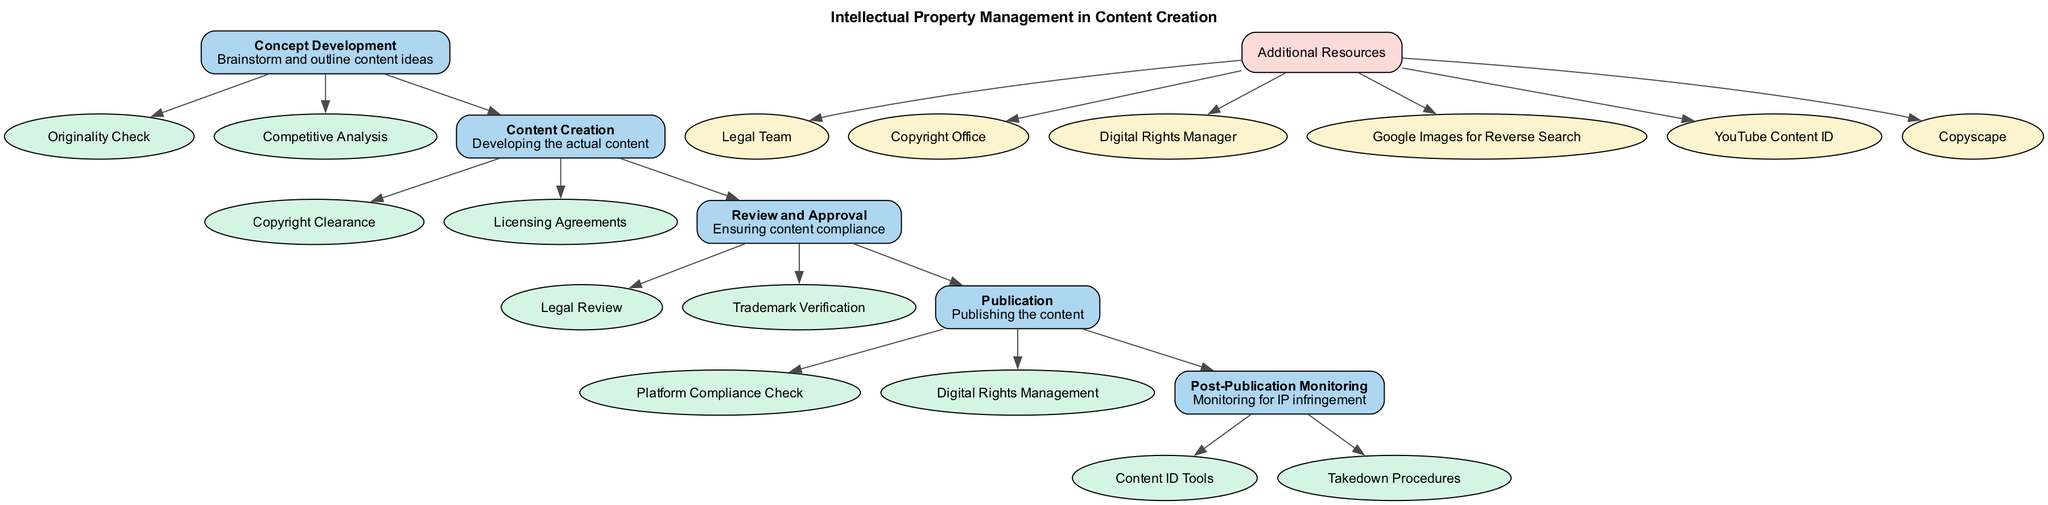What is the title of the diagram? The title is shown at the top of the diagram, which states "Intellectual Property Management in Content Creation."
Answer: Intellectual Property Management in Content Creation How many stages are there in the pathway? By counting the stages listed in the diagram, there are five distinct stages.
Answer: 5 What is the first stage of the pathway? The first stage is represented at the top and labeled as "Concept Development."
Answer: Concept Development What key element is associated with the "Content Creation" stage? The key elements associated with the "Content Creation" stage are shown as ellipses connected to that stage; one of them is "Copyright Clearance."
Answer: Copyright Clearance Which stage follows "Review and Approval"? The diagram indicates a direct connection from "Review and Approval" to the next stage, which is "Publication."
Answer: Publication What additional resource category is mentioned in the diagram? The diagram lists "Additional Resources" and details that contain contacts and tools, making it a category of additional resources.
Answer: Additional Resources What is the purpose of "Post-Publication Monitoring"? This stage is about monitoring for potential IP infringement, indicating its importance in protecting intellectual property.
Answer: Monitoring for IP infringement How many key elements are listed under "Post-Publication Monitoring"? The diagram shows that there are two key elements listed under "Post-Publication Monitoring."
Answer: 2 What tool is recommended for reverse image search? The diagram lists "Google Images for Reverse Search" as a tool in the "Additional Resources" section.
Answer: Google Images for Reverse Search Which stage includes "Trademark Verification" as a key element? "Trademark Verification" is identified as a key element of the "Review and Approval" stage, based on its connection in the diagram.
Answer: Review and Approval 